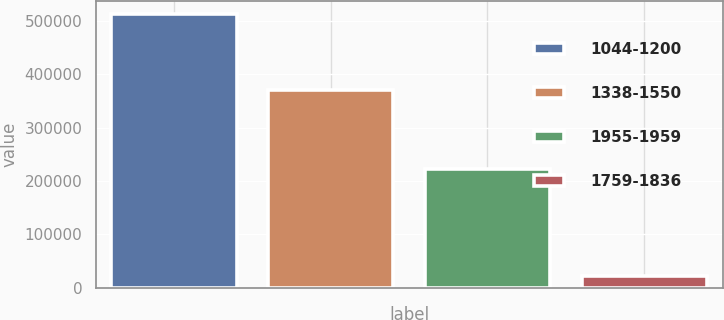Convert chart. <chart><loc_0><loc_0><loc_500><loc_500><bar_chart><fcel>1044-1200<fcel>1338-1550<fcel>1955-1959<fcel>1759-1836<nl><fcel>512622<fcel>370661<fcel>222293<fcel>21000<nl></chart> 